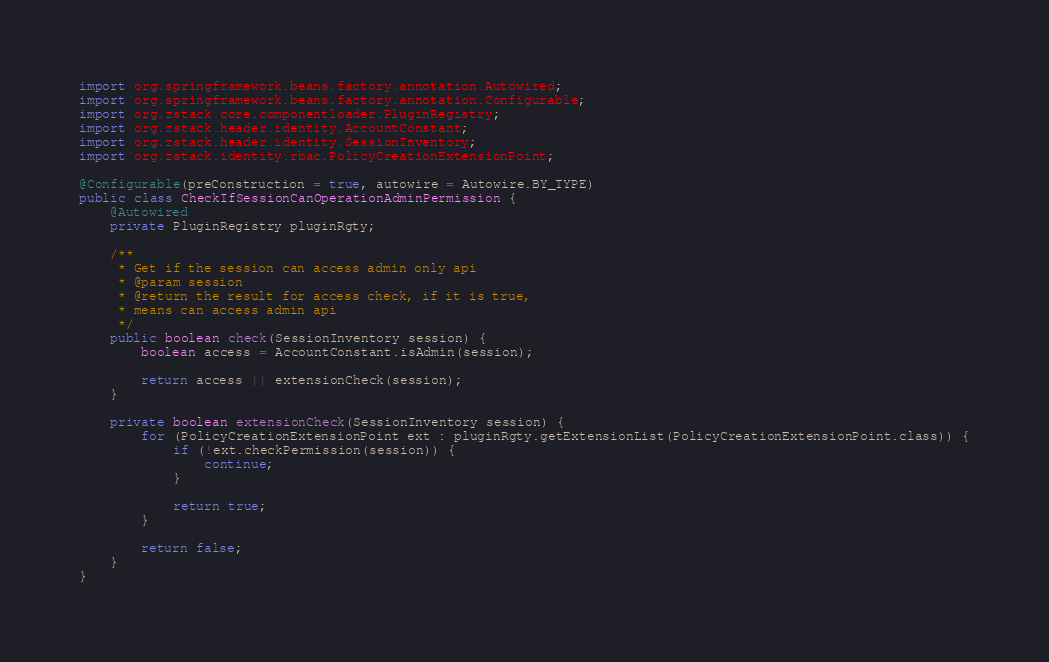Convert code to text. <code><loc_0><loc_0><loc_500><loc_500><_Java_>import org.springframework.beans.factory.annotation.Autowired;
import org.springframework.beans.factory.annotation.Configurable;
import org.zstack.core.componentloader.PluginRegistry;
import org.zstack.header.identity.AccountConstant;
import org.zstack.header.identity.SessionInventory;
import org.zstack.identity.rbac.PolicyCreationExtensionPoint;

@Configurable(preConstruction = true, autowire = Autowire.BY_TYPE)
public class CheckIfSessionCanOperationAdminPermission {
    @Autowired
    private PluginRegistry pluginRgty;

    /**
     * Get if the session can access admin only api
     * @param session
     * @return the result for access check, if it is true,
     * means can access admin api
     */
    public boolean check(SessionInventory session) {
        boolean access = AccountConstant.isAdmin(session);

        return access || extensionCheck(session);
    }

    private boolean extensionCheck(SessionInventory session) {
        for (PolicyCreationExtensionPoint ext : pluginRgty.getExtensionList(PolicyCreationExtensionPoint.class)) {
            if (!ext.checkPermission(session)) {
                continue;
            }

            return true;
        }

        return false;
    }
}
</code> 